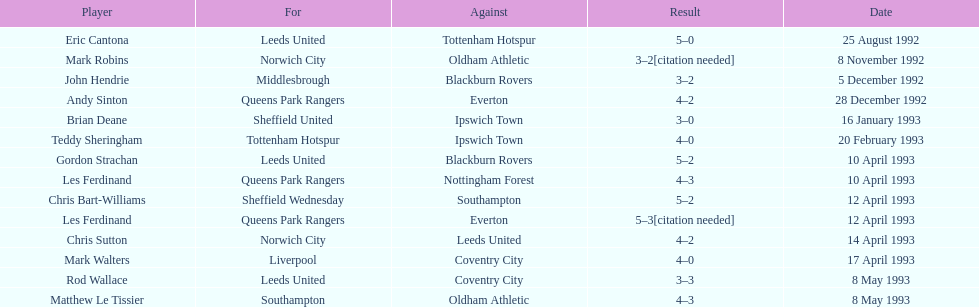Who is john hendrie's team? Middlesbrough. 